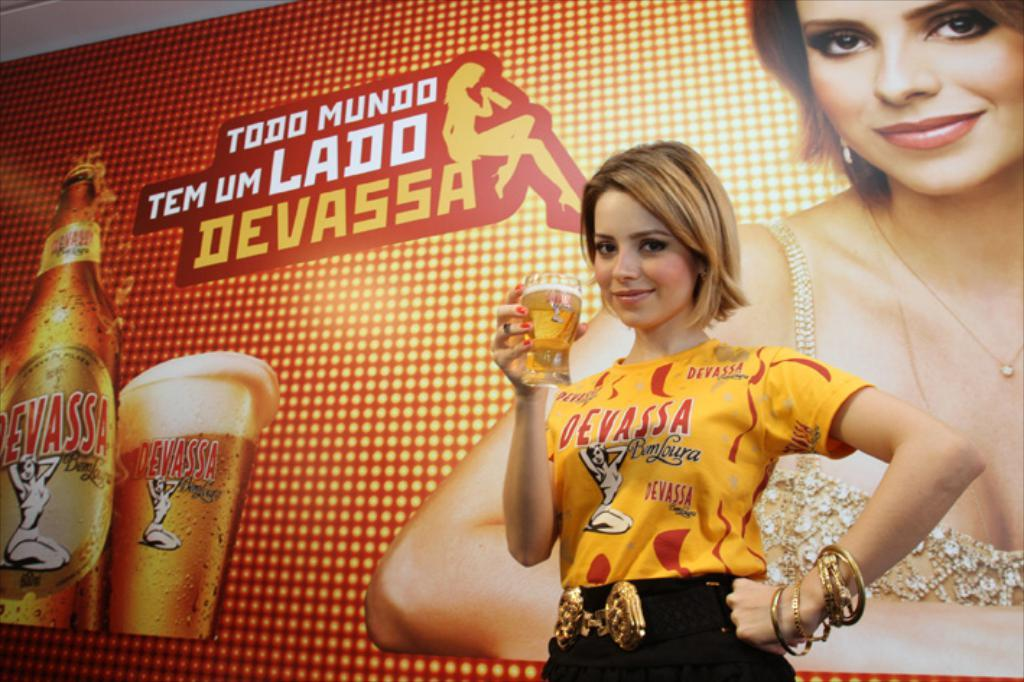<image>
Share a concise interpretation of the image provided. Woman drinking a beer in front of todd mundo advertisement 